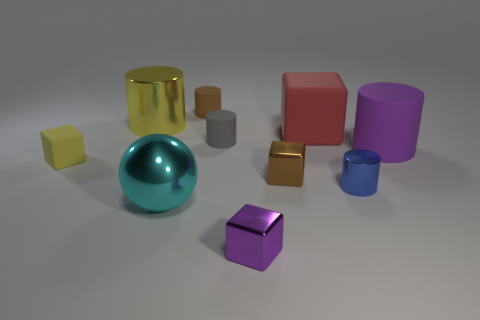Subtract all tiny brown cylinders. How many cylinders are left? 4 Subtract all brown cylinders. How many cylinders are left? 4 Subtract 1 cubes. How many cubes are left? 3 Subtract all gray blocks. Subtract all yellow cylinders. How many blocks are left? 4 Subtract all cubes. How many objects are left? 6 Add 8 large brown shiny spheres. How many large brown shiny spheres exist? 8 Subtract 1 brown blocks. How many objects are left? 9 Subtract all tiny yellow blocks. Subtract all tiny purple shiny objects. How many objects are left? 8 Add 1 big metallic spheres. How many big metallic spheres are left? 2 